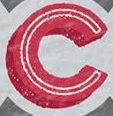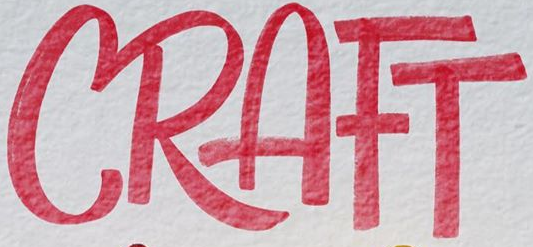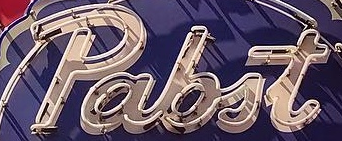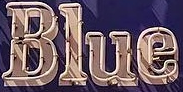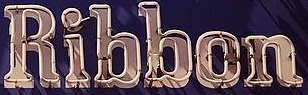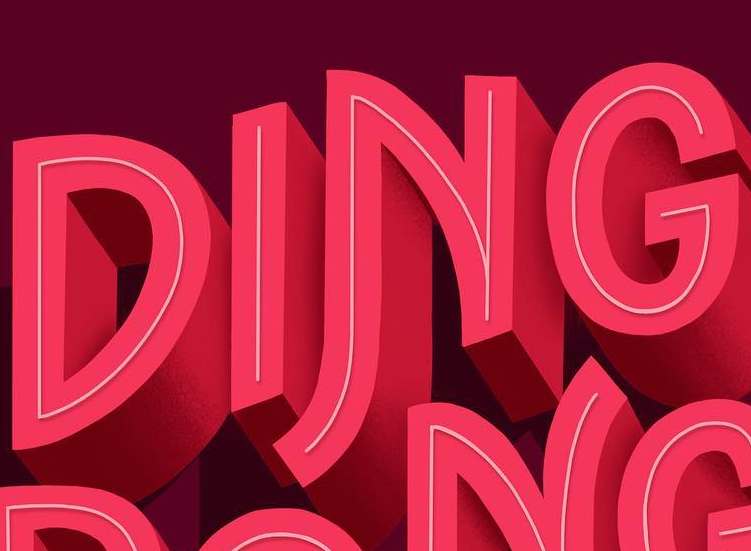Identify the words shown in these images in order, separated by a semicolon. C; CRAFT; pabit; Blue; Ribbon; DING 